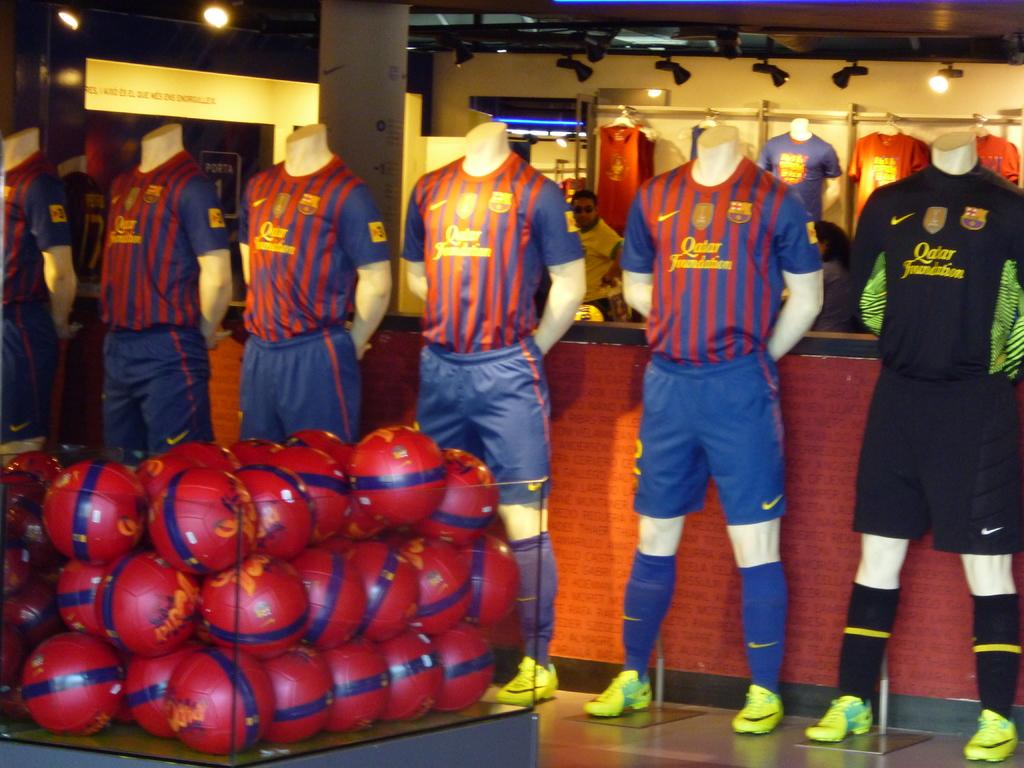What sponsor is mentioned on the jerseys?
Make the answer very short. Qatar foundation. What language is the logo on the shirts?
Ensure brevity in your answer.  Unanswerable. 